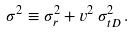Convert formula to latex. <formula><loc_0><loc_0><loc_500><loc_500>\sigma ^ { 2 } \equiv \sigma _ { r } ^ { 2 } + v ^ { 2 } \, \sigma _ { t D } ^ { 2 } \, .</formula> 